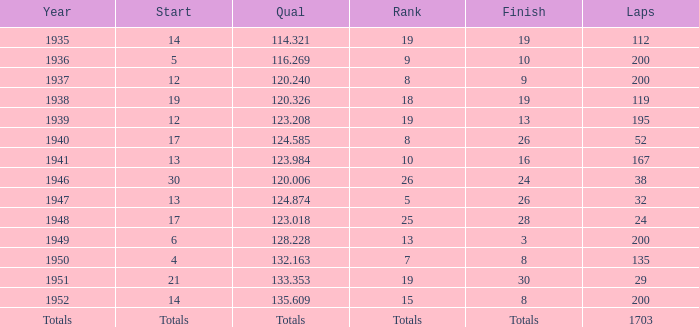The Qual of 120.006 took place in what year? 1946.0. 